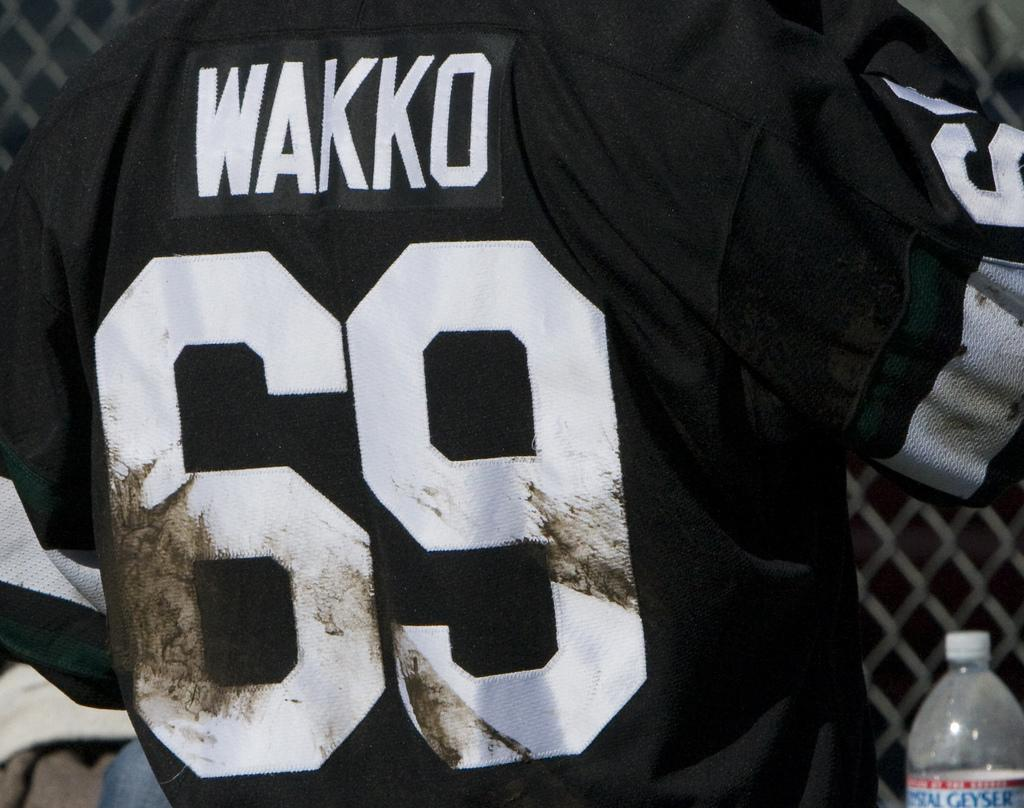<image>
Create a compact narrative representing the image presented. player 69, wakko,  with his back turned as he stands by a chain link fence 